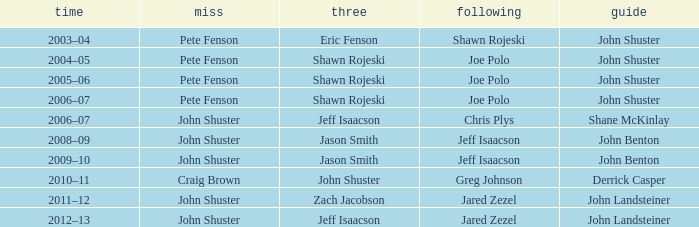Who was the lead player alongside john shuster as skip, chris plys in the second position, and jeff isaacson in the third position? Shane McKinlay. 